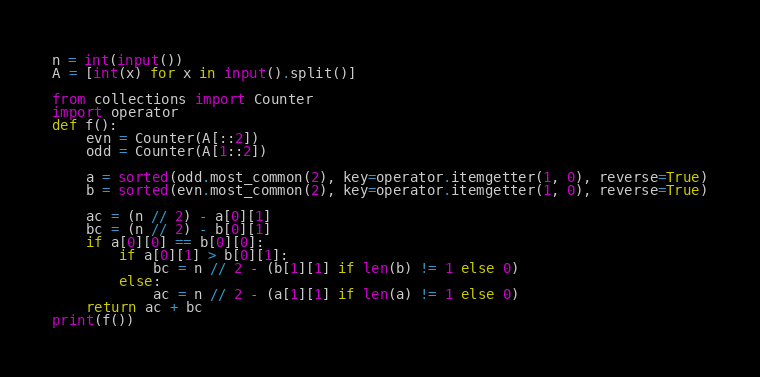Convert code to text. <code><loc_0><loc_0><loc_500><loc_500><_Python_>n = int(input())
A = [int(x) for x in input().split()]

from collections import Counter
import operator
def f():
    evn = Counter(A[::2])
    odd = Counter(A[1::2])

    a = sorted(odd.most_common(2), key=operator.itemgetter(1, 0), reverse=True)
    b = sorted(evn.most_common(2), key=operator.itemgetter(1, 0), reverse=True)
    
    ac = (n // 2) - a[0][1]
    bc = (n // 2) - b[0][1]
    if a[0][0] == b[0][0]:
        if a[0][1] > b[0][1]:
            bc = n // 2 - (b[1][1] if len(b) != 1 else 0)
        else:
            ac = n // 2 - (a[1][1] if len(a) != 1 else 0)
    return ac + bc
print(f())</code> 